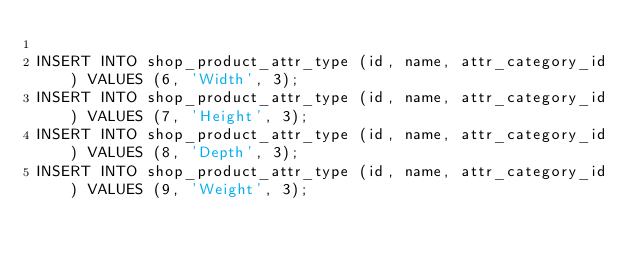<code> <loc_0><loc_0><loc_500><loc_500><_SQL_>
INSERT INTO shop_product_attr_type (id, name, attr_category_id) VALUES (6, 'Width', 3);
INSERT INTO shop_product_attr_type (id, name, attr_category_id) VALUES (7, 'Height', 3);
INSERT INTO shop_product_attr_type (id, name, attr_category_id) VALUES (8, 'Depth', 3);
INSERT INTO shop_product_attr_type (id, name, attr_category_id) VALUES (9, 'Weight', 3);
</code> 